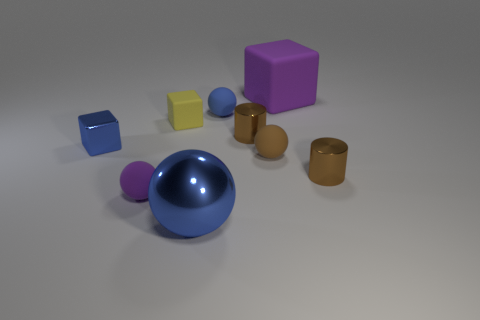Subtract all gray cylinders. Subtract all blue spheres. How many cylinders are left? 2 Add 1 rubber objects. How many objects exist? 10 Subtract all blocks. How many objects are left? 6 Add 8 tiny purple metallic cylinders. How many tiny purple metallic cylinders exist? 8 Subtract 0 red cubes. How many objects are left? 9 Subtract all shiny objects. Subtract all gray rubber things. How many objects are left? 5 Add 6 yellow cubes. How many yellow cubes are left? 7 